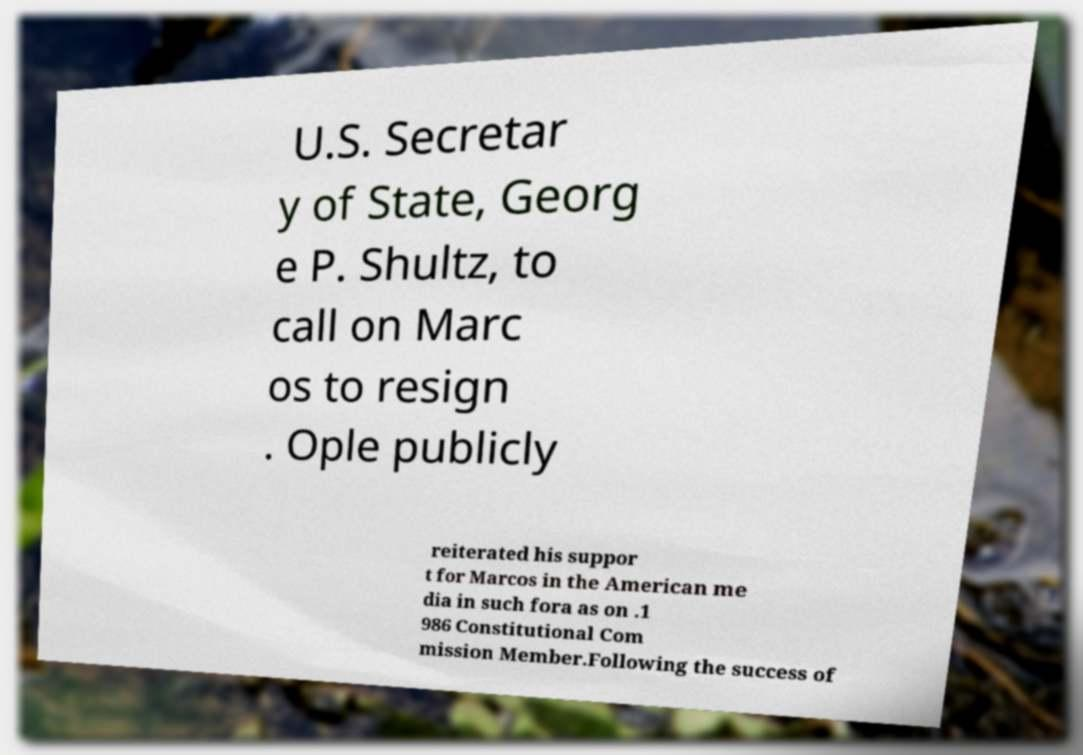Can you accurately transcribe the text from the provided image for me? U.S. Secretar y of State, Georg e P. Shultz, to call on Marc os to resign . Ople publicly reiterated his suppor t for Marcos in the American me dia in such fora as on .1 986 Constitutional Com mission Member.Following the success of 